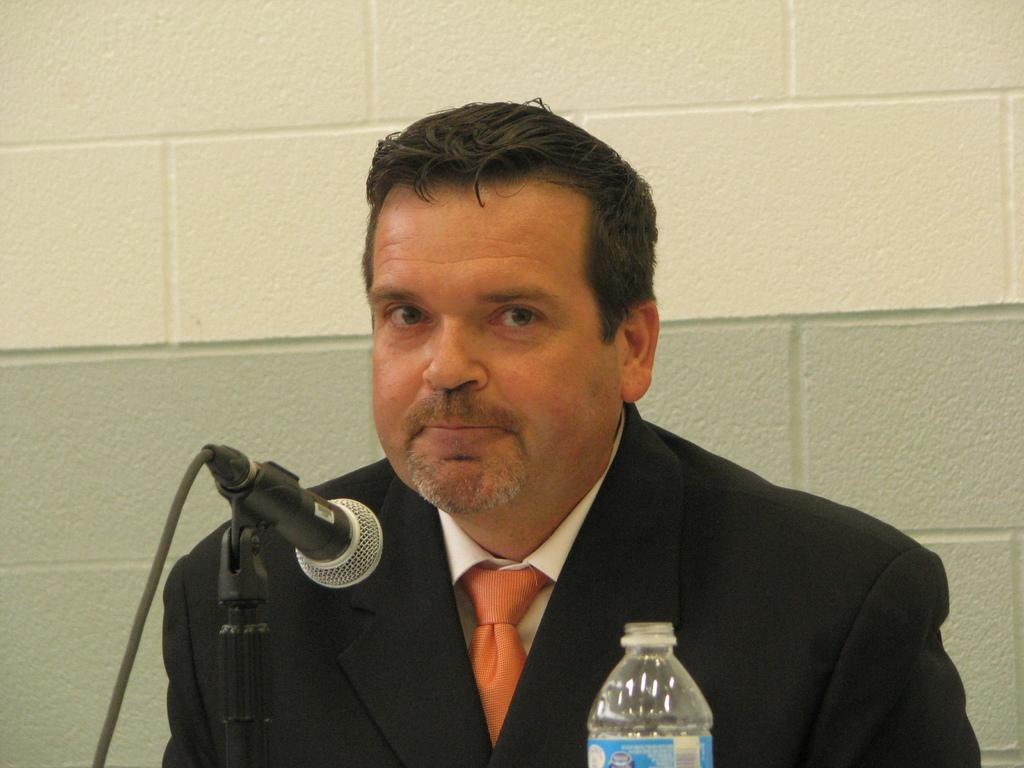Who is the main subject in the image? There is a man in the image. What is in front of the man? There is a mic and a bottle in front of the man. What can be seen in the background of the image? There is a wall in the background of the image. What type of substance is the man sneezing in the image? There is no sneezing or substance present in the image. What role does the spoon play in the image? There is no spoon present in the image. 